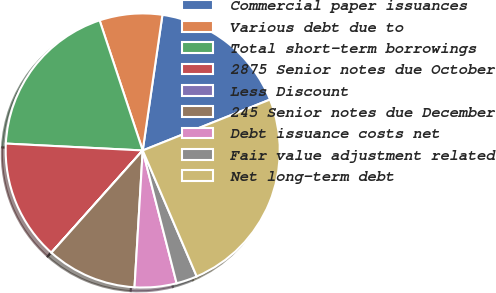<chart> <loc_0><loc_0><loc_500><loc_500><pie_chart><fcel>Commercial paper issuances<fcel>Various debt due to<fcel>Total short-term borrowings<fcel>2875 Senior notes due October<fcel>Less Discount<fcel>245 Senior notes due December<fcel>Debt issuance costs net<fcel>Fair value adjustment related<fcel>Net long-term debt<nl><fcel>16.65%<fcel>7.39%<fcel>19.11%<fcel>14.19%<fcel>0.01%<fcel>10.65%<fcel>4.93%<fcel>2.47%<fcel>24.61%<nl></chart> 